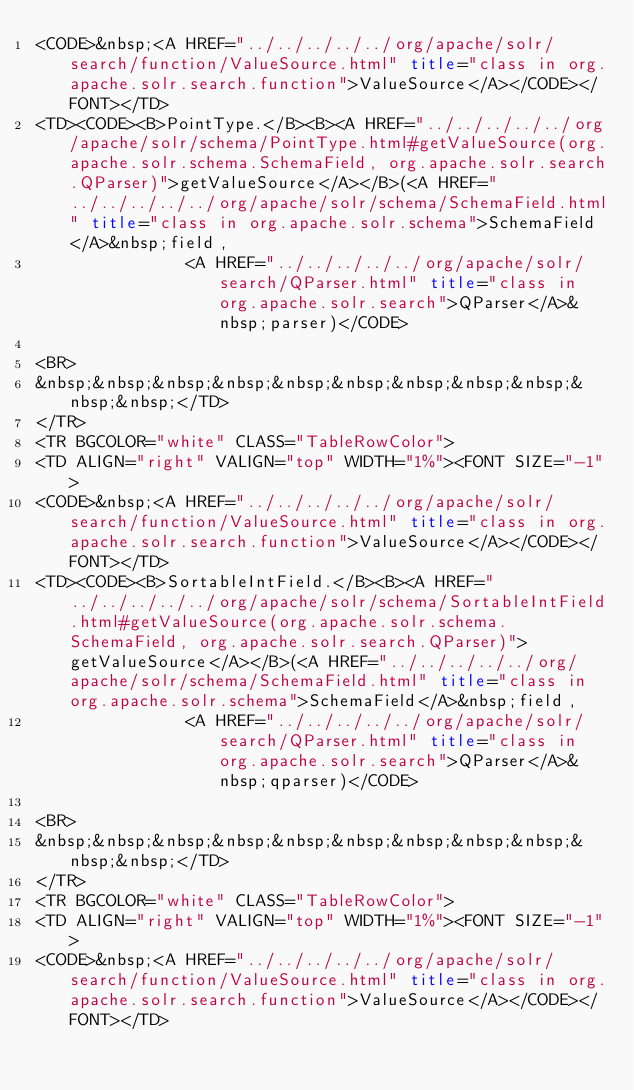<code> <loc_0><loc_0><loc_500><loc_500><_HTML_><CODE>&nbsp;<A HREF="../../../../../org/apache/solr/search/function/ValueSource.html" title="class in org.apache.solr.search.function">ValueSource</A></CODE></FONT></TD>
<TD><CODE><B>PointType.</B><B><A HREF="../../../../../org/apache/solr/schema/PointType.html#getValueSource(org.apache.solr.schema.SchemaField, org.apache.solr.search.QParser)">getValueSource</A></B>(<A HREF="../../../../../org/apache/solr/schema/SchemaField.html" title="class in org.apache.solr.schema">SchemaField</A>&nbsp;field,
               <A HREF="../../../../../org/apache/solr/search/QParser.html" title="class in org.apache.solr.search">QParser</A>&nbsp;parser)</CODE>

<BR>
&nbsp;&nbsp;&nbsp;&nbsp;&nbsp;&nbsp;&nbsp;&nbsp;&nbsp;&nbsp;&nbsp;</TD>
</TR>
<TR BGCOLOR="white" CLASS="TableRowColor">
<TD ALIGN="right" VALIGN="top" WIDTH="1%"><FONT SIZE="-1">
<CODE>&nbsp;<A HREF="../../../../../org/apache/solr/search/function/ValueSource.html" title="class in org.apache.solr.search.function">ValueSource</A></CODE></FONT></TD>
<TD><CODE><B>SortableIntField.</B><B><A HREF="../../../../../org/apache/solr/schema/SortableIntField.html#getValueSource(org.apache.solr.schema.SchemaField, org.apache.solr.search.QParser)">getValueSource</A></B>(<A HREF="../../../../../org/apache/solr/schema/SchemaField.html" title="class in org.apache.solr.schema">SchemaField</A>&nbsp;field,
               <A HREF="../../../../../org/apache/solr/search/QParser.html" title="class in org.apache.solr.search">QParser</A>&nbsp;qparser)</CODE>

<BR>
&nbsp;&nbsp;&nbsp;&nbsp;&nbsp;&nbsp;&nbsp;&nbsp;&nbsp;&nbsp;&nbsp;</TD>
</TR>
<TR BGCOLOR="white" CLASS="TableRowColor">
<TD ALIGN="right" VALIGN="top" WIDTH="1%"><FONT SIZE="-1">
<CODE>&nbsp;<A HREF="../../../../../org/apache/solr/search/function/ValueSource.html" title="class in org.apache.solr.search.function">ValueSource</A></CODE></FONT></TD></code> 